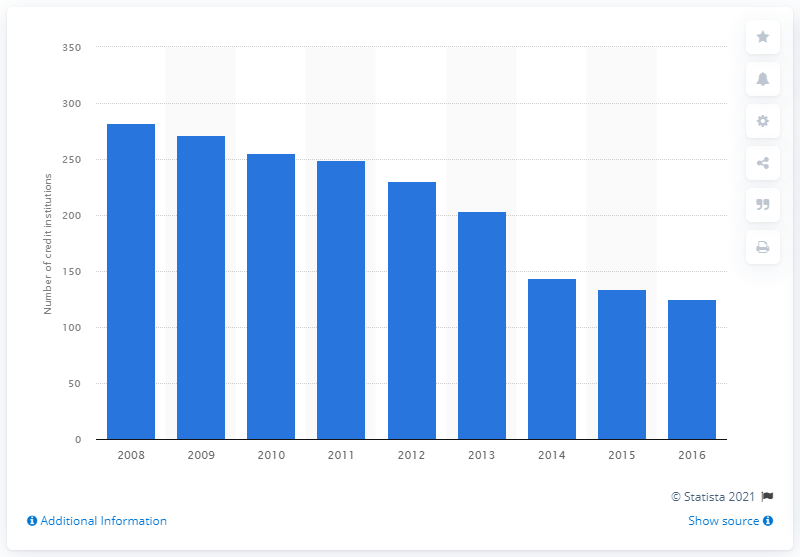Point out several critical features in this image. In 2016, there were 125 Microfinance Institutions (MFIs) operating in Spain. 